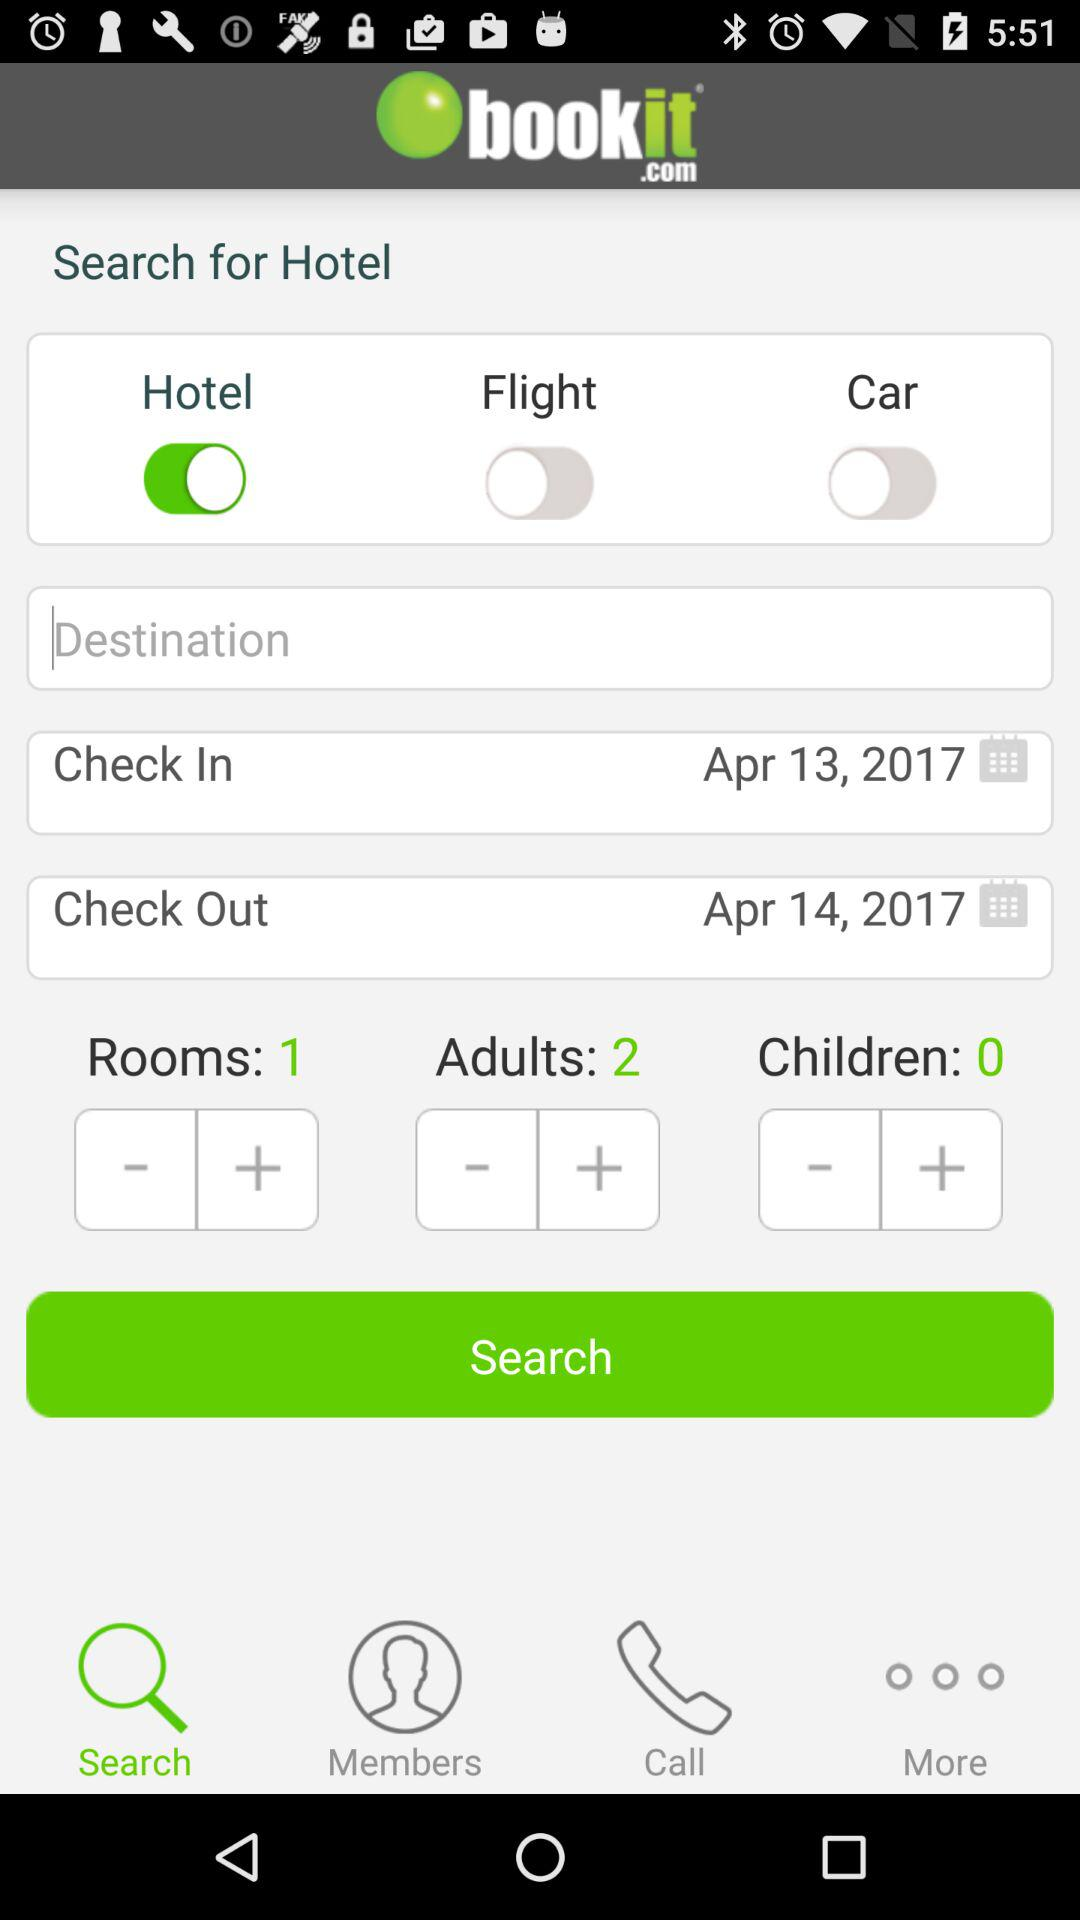What is the status of "Hotel"? The status of "Hotel" is "on". 